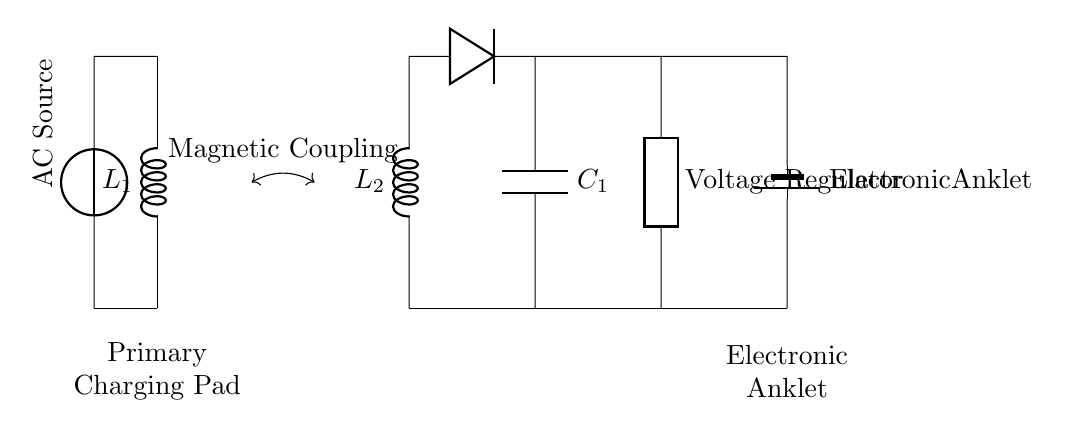What is the type of charging system used? The circuit diagram illustrates an inductive charging system, which uses electromagnetic induction to transfer energy wirelessly between the primary coil and the secondary coil.
Answer: Inductive charging system How many inductors are present in the circuit? There are two inductors in the circuit, labeled as L1 and L2, representing the primary and secondary coils.
Answer: Two What component is used for rectification? A diode is employed in the circuit to rectify the alternating current from the secondary coil into direct current, facilitating the charging of the electronic anklet.
Answer: Diode What is the purpose of the voltage regulator in this circuit? The voltage regulator stabilizes the output voltage supplied to the electronic anklet, ensuring consistent performance and preventing damage.
Answer: Stabilization What does the magnetic coupling represent in this circuit? Magnetic coupling denotes the interaction between the magnetic fields of the primary and secondary coils, allowing for the transfer of energy without direct electrical connections.
Answer: Energy transfer What type of output is delivered to the electronic anklet? The circuit provides a direct current output to the electronic anklet, which is essential for its proper operation.
Answer: Direct current 